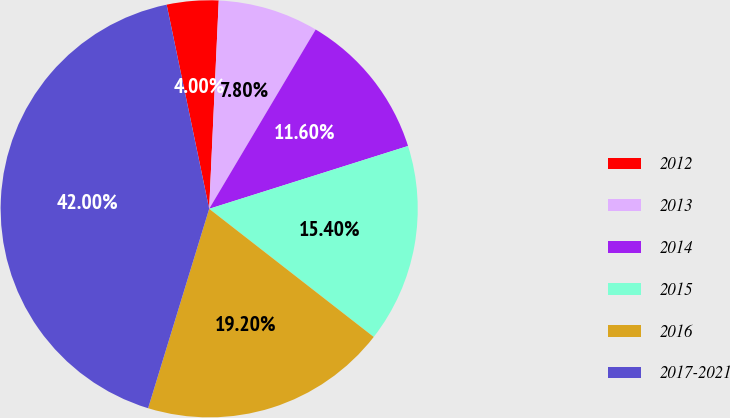Convert chart. <chart><loc_0><loc_0><loc_500><loc_500><pie_chart><fcel>2012<fcel>2013<fcel>2014<fcel>2015<fcel>2016<fcel>2017-2021<nl><fcel>4.0%<fcel>7.8%<fcel>11.6%<fcel>15.4%<fcel>19.2%<fcel>42.0%<nl></chart> 